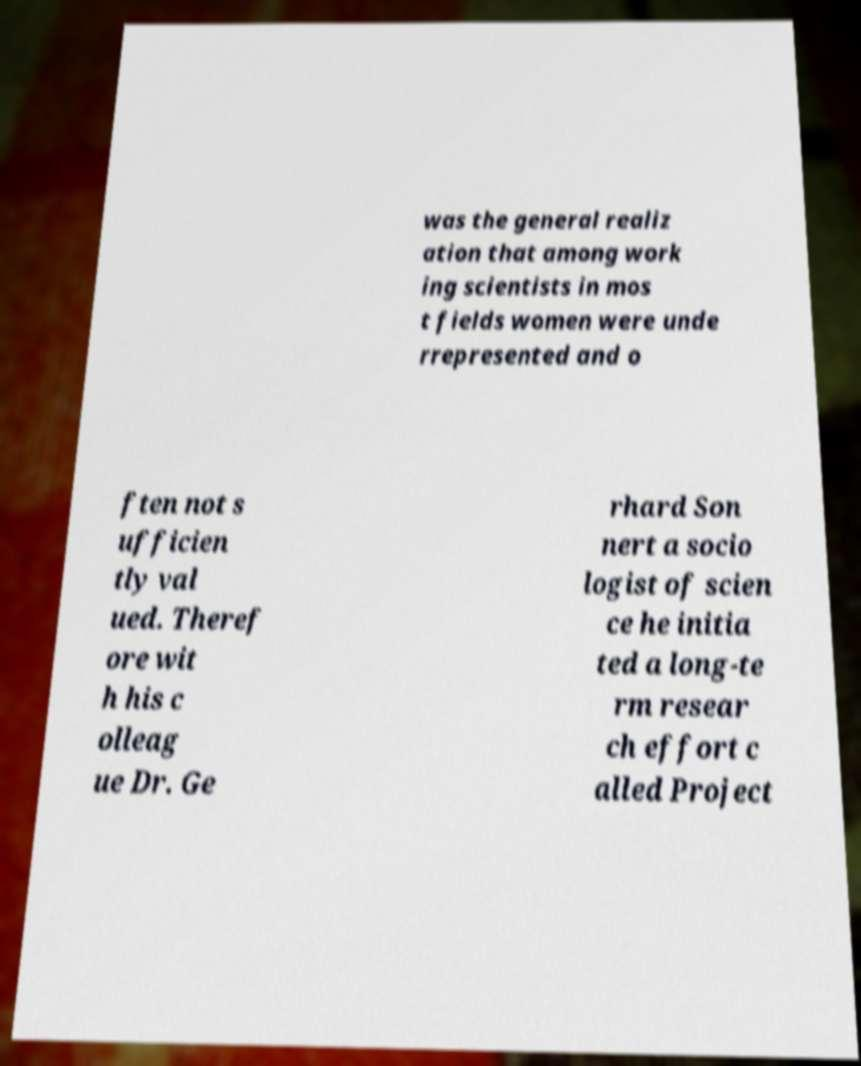There's text embedded in this image that I need extracted. Can you transcribe it verbatim? was the general realiz ation that among work ing scientists in mos t fields women were unde rrepresented and o ften not s ufficien tly val ued. Theref ore wit h his c olleag ue Dr. Ge rhard Son nert a socio logist of scien ce he initia ted a long-te rm resear ch effort c alled Project 